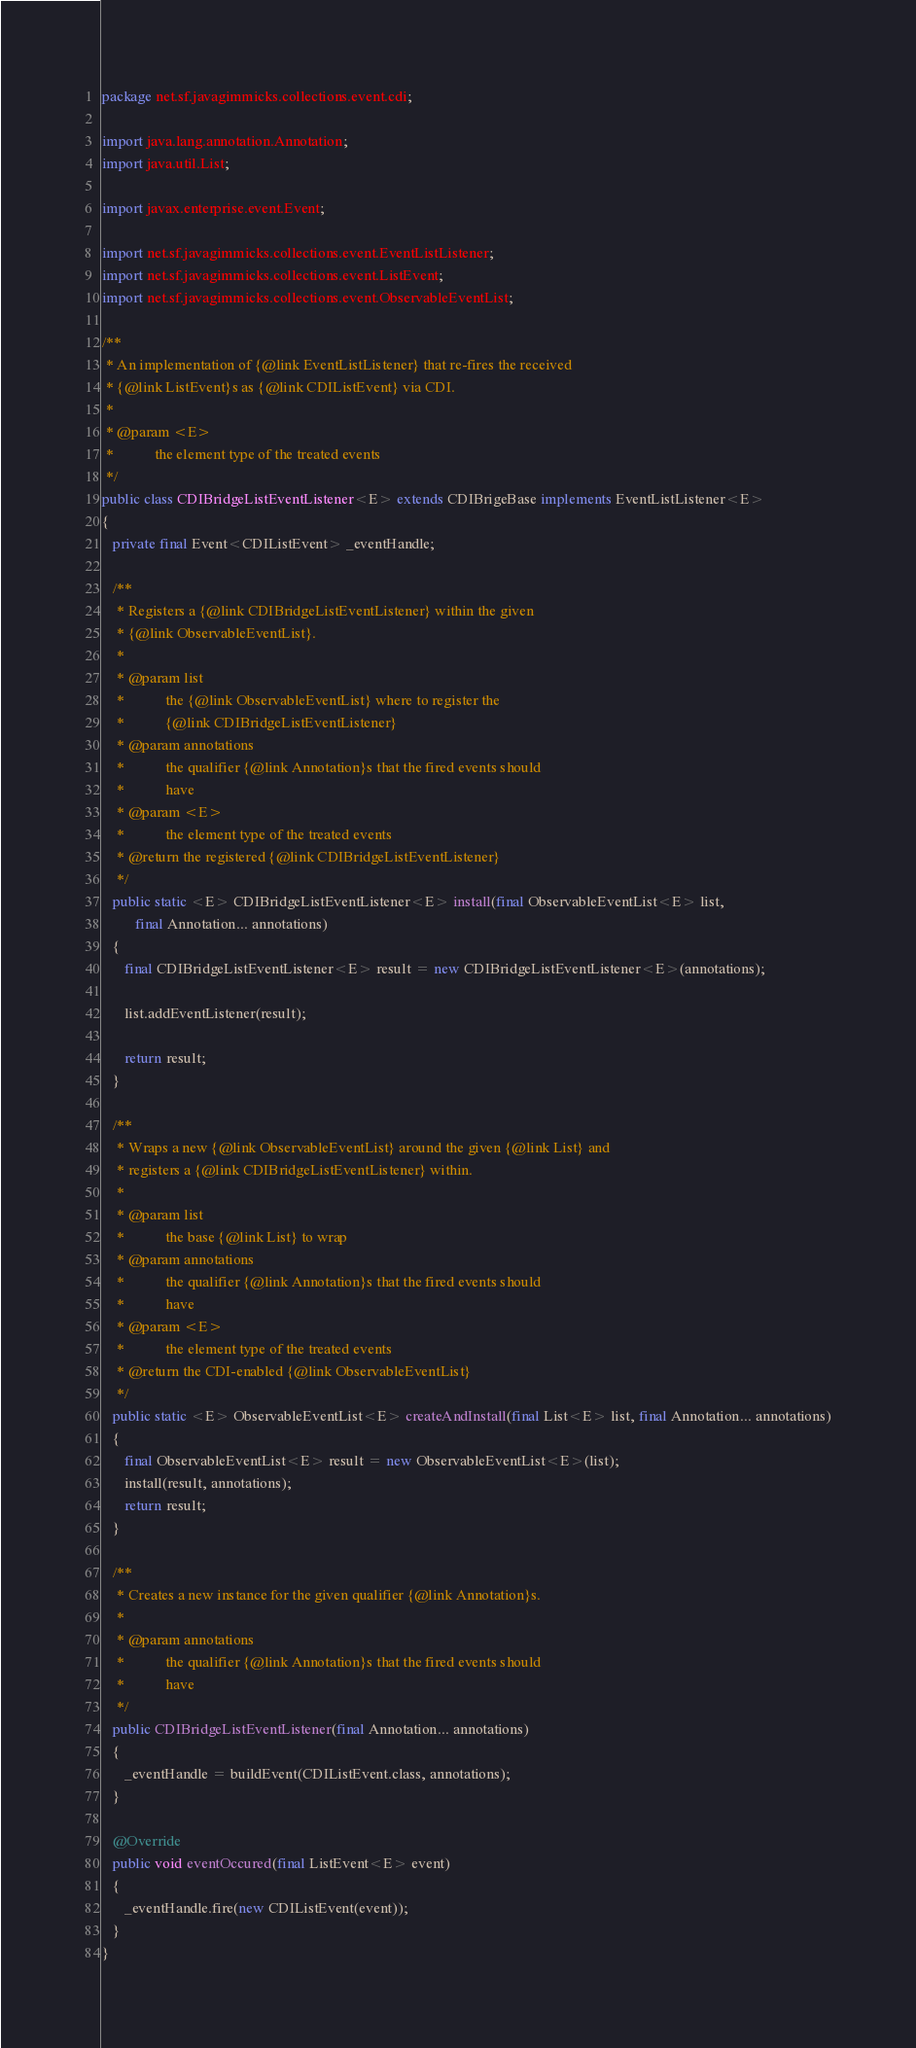<code> <loc_0><loc_0><loc_500><loc_500><_Java_>package net.sf.javagimmicks.collections.event.cdi;

import java.lang.annotation.Annotation;
import java.util.List;

import javax.enterprise.event.Event;

import net.sf.javagimmicks.collections.event.EventListListener;
import net.sf.javagimmicks.collections.event.ListEvent;
import net.sf.javagimmicks.collections.event.ObservableEventList;

/**
 * An implementation of {@link EventListListener} that re-fires the received
 * {@link ListEvent}s as {@link CDIListEvent} via CDI.
 * 
 * @param <E>
 *           the element type of the treated events
 */
public class CDIBridgeListEventListener<E> extends CDIBrigeBase implements EventListListener<E>
{
   private final Event<CDIListEvent> _eventHandle;

   /**
    * Registers a {@link CDIBridgeListEventListener} within the given
    * {@link ObservableEventList}.
    * 
    * @param list
    *           the {@link ObservableEventList} where to register the
    *           {@link CDIBridgeListEventListener}
    * @param annotations
    *           the qualifier {@link Annotation}s that the fired events should
    *           have
    * @param <E>
    *           the element type of the treated events
    * @return the registered {@link CDIBridgeListEventListener}
    */
   public static <E> CDIBridgeListEventListener<E> install(final ObservableEventList<E> list,
         final Annotation... annotations)
   {
      final CDIBridgeListEventListener<E> result = new CDIBridgeListEventListener<E>(annotations);

      list.addEventListener(result);

      return result;
   }

   /**
    * Wraps a new {@link ObservableEventList} around the given {@link List} and
    * registers a {@link CDIBridgeListEventListener} within.
    * 
    * @param list
    *           the base {@link List} to wrap
    * @param annotations
    *           the qualifier {@link Annotation}s that the fired events should
    *           have
    * @param <E>
    *           the element type of the treated events
    * @return the CDI-enabled {@link ObservableEventList}
    */
   public static <E> ObservableEventList<E> createAndInstall(final List<E> list, final Annotation... annotations)
   {
      final ObservableEventList<E> result = new ObservableEventList<E>(list);
      install(result, annotations);
      return result;
   }

   /**
    * Creates a new instance for the given qualifier {@link Annotation}s.
    * 
    * @param annotations
    *           the qualifier {@link Annotation}s that the fired events should
    *           have
    */
   public CDIBridgeListEventListener(final Annotation... annotations)
   {
      _eventHandle = buildEvent(CDIListEvent.class, annotations);
   }

   @Override
   public void eventOccured(final ListEvent<E> event)
   {
      _eventHandle.fire(new CDIListEvent(event));
   }
}
</code> 